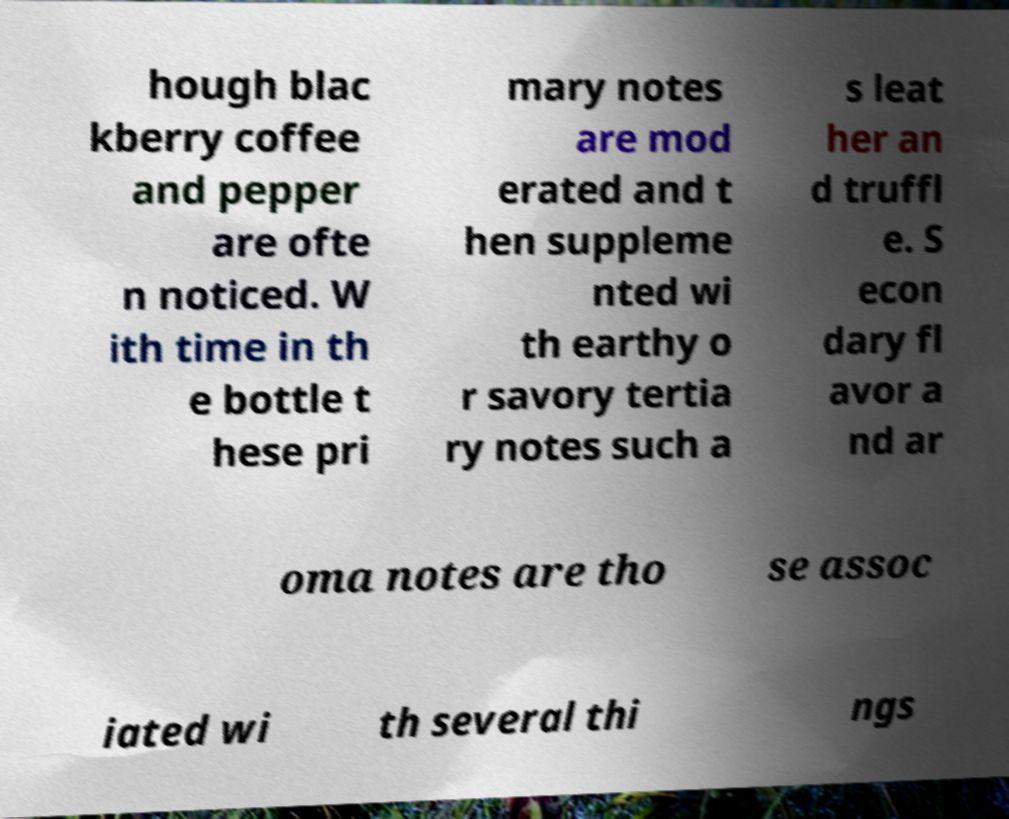What messages or text are displayed in this image? I need them in a readable, typed format. hough blac kberry coffee and pepper are ofte n noticed. W ith time in th e bottle t hese pri mary notes are mod erated and t hen suppleme nted wi th earthy o r savory tertia ry notes such a s leat her an d truffl e. S econ dary fl avor a nd ar oma notes are tho se assoc iated wi th several thi ngs 